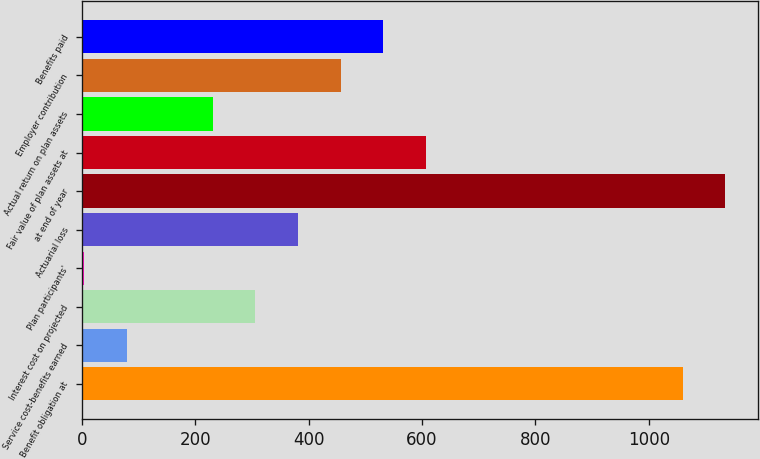<chart> <loc_0><loc_0><loc_500><loc_500><bar_chart><fcel>Benefit obligation at<fcel>Service cost-benefits earned<fcel>Interest cost on projected<fcel>Plan participants'<fcel>Actuarial loss<fcel>at end of year<fcel>Fair value of plan assets at<fcel>Actual return on plan assets<fcel>Employer contribution<fcel>Benefits paid<nl><fcel>1059.6<fcel>79.4<fcel>305.6<fcel>4<fcel>381<fcel>1135<fcel>607.2<fcel>230.2<fcel>456.4<fcel>531.8<nl></chart> 